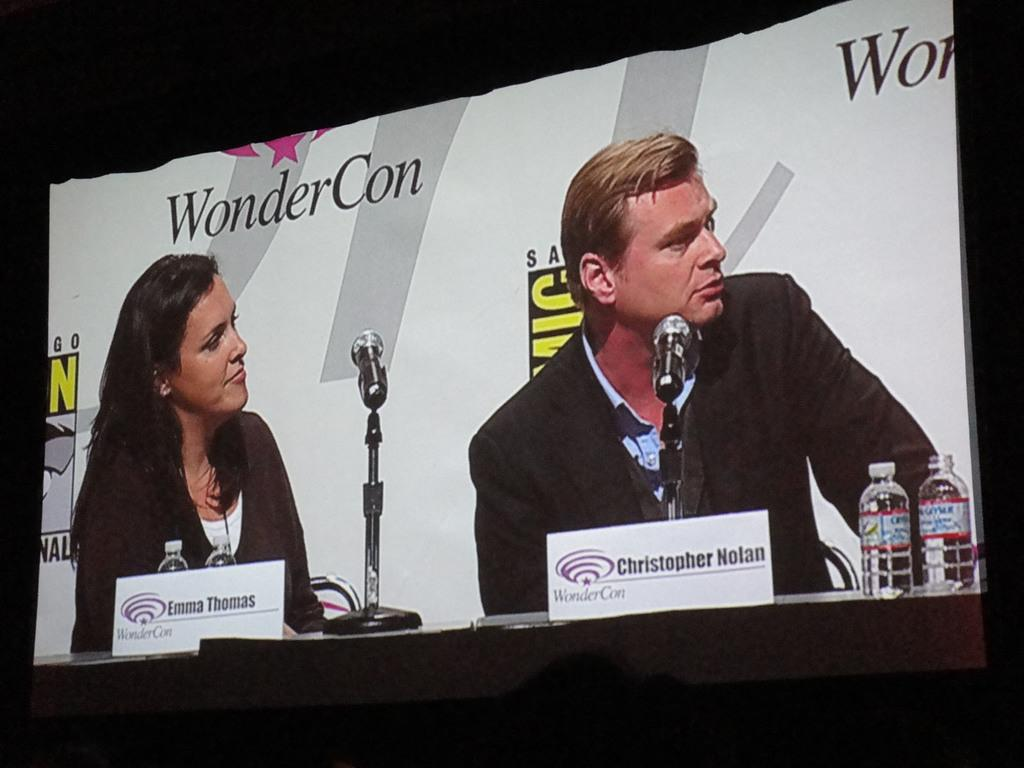What is the main object in the image? There is a screen in the image. What can be seen on the screen? A man and a woman are sitting in front of mics, and there are bottles and name boards visible. What are the man and woman doing in the image? They are sitting in front of mics, which suggests they might be recording something or participating in a broadcast. What else can be seen on the screen? Name boards are present on the screen. How many bananas are hanging from the rail in the image? There is no rail or bananas present in the image. 